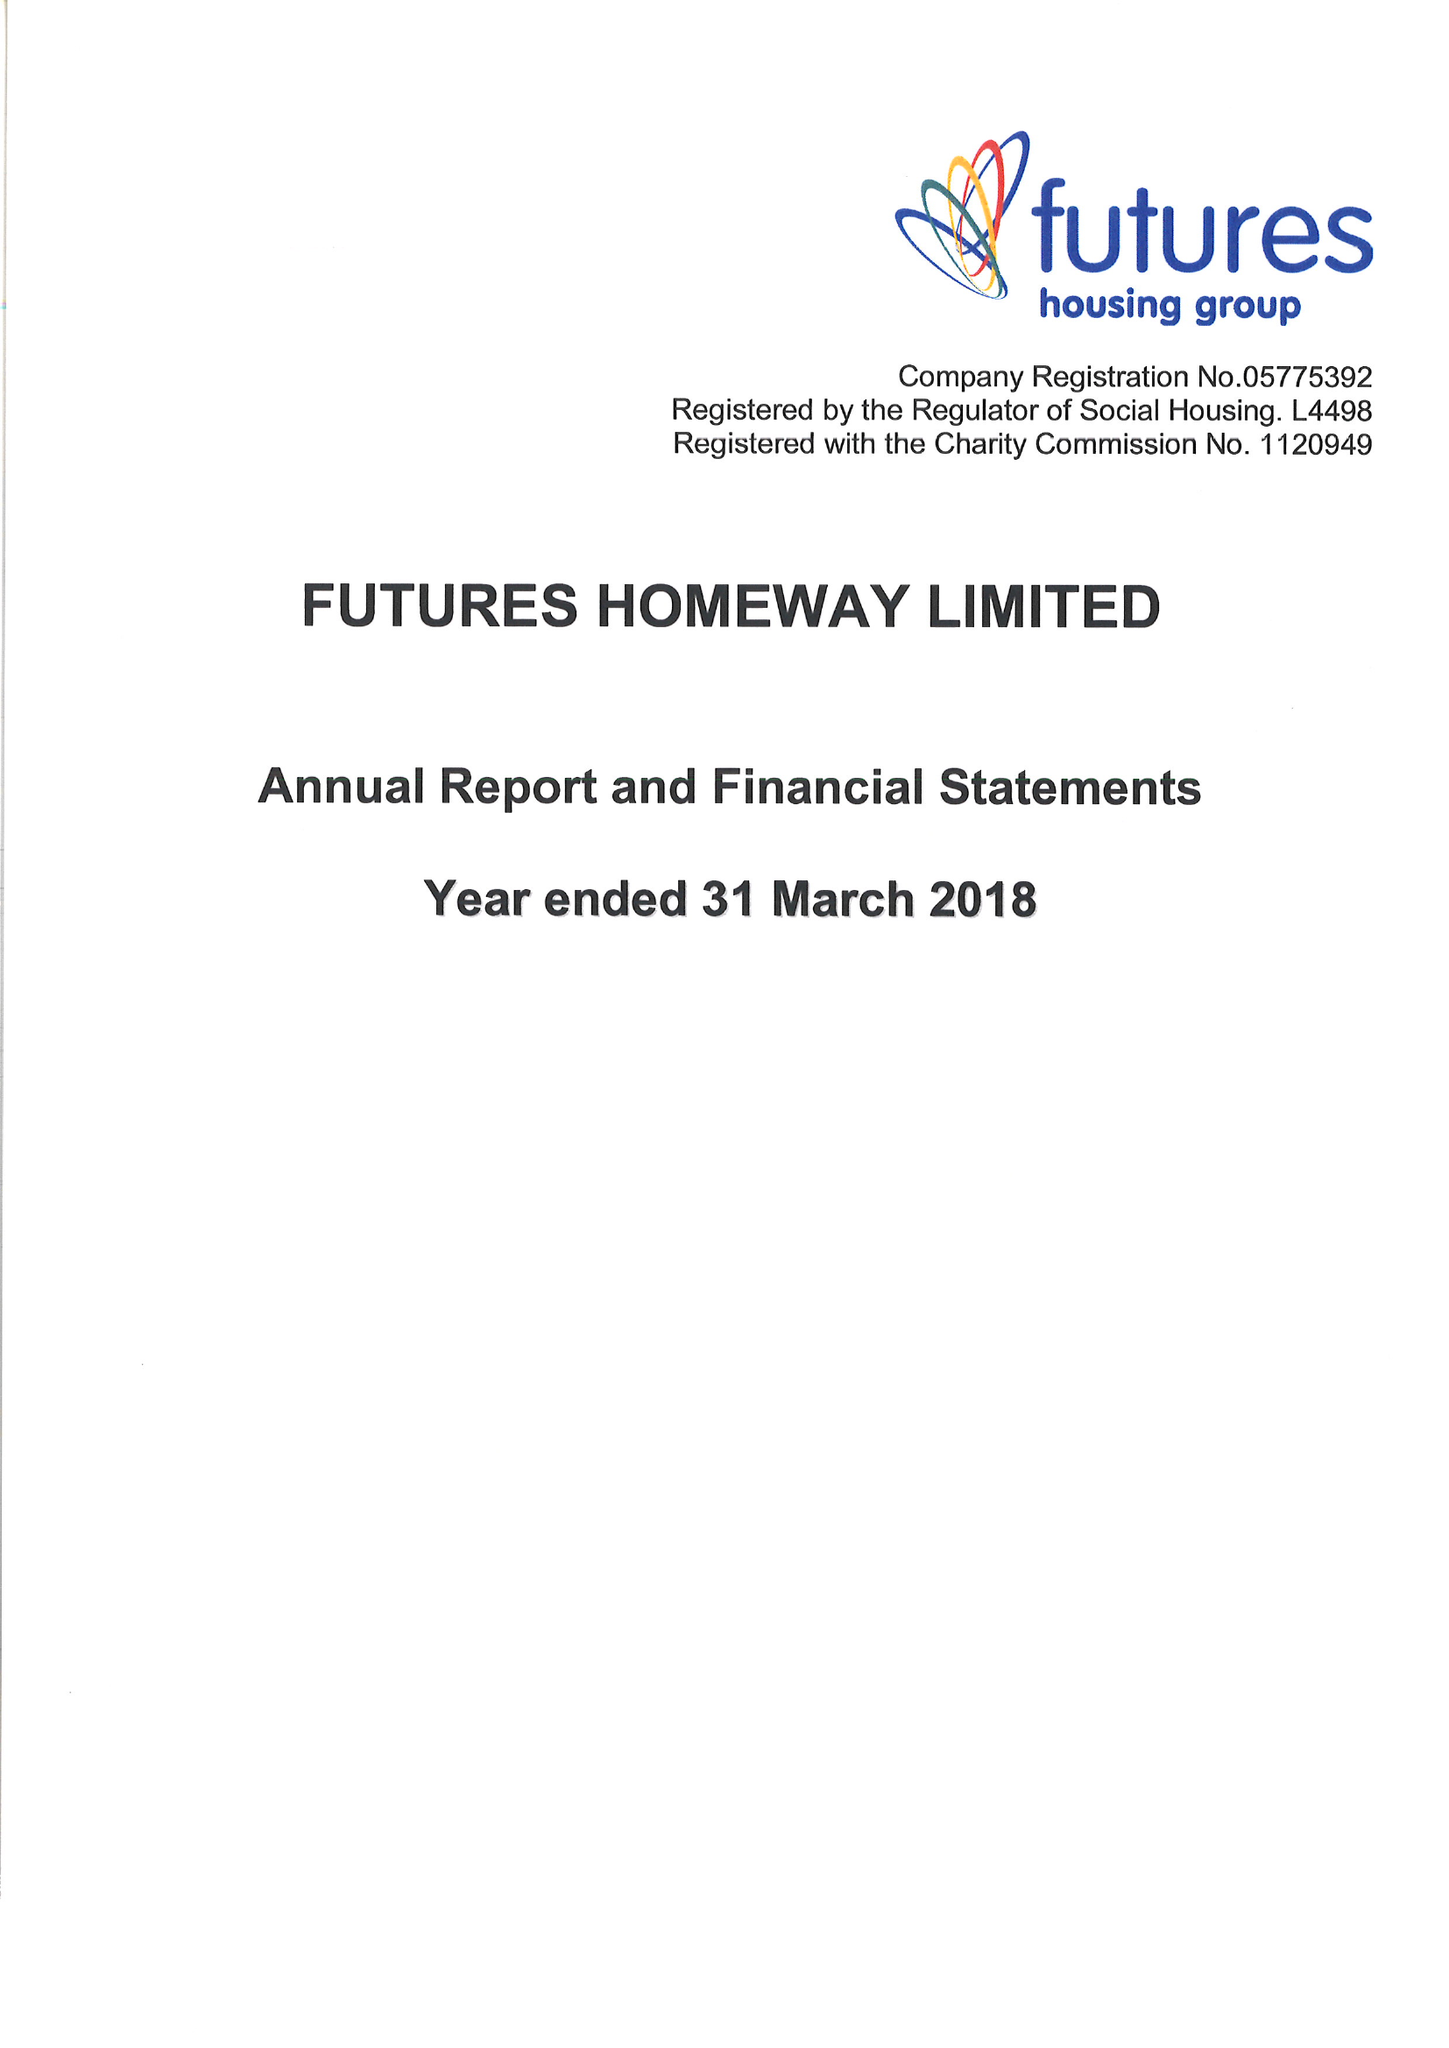What is the value for the address__street_line?
Answer the question using a single word or phrase. None 